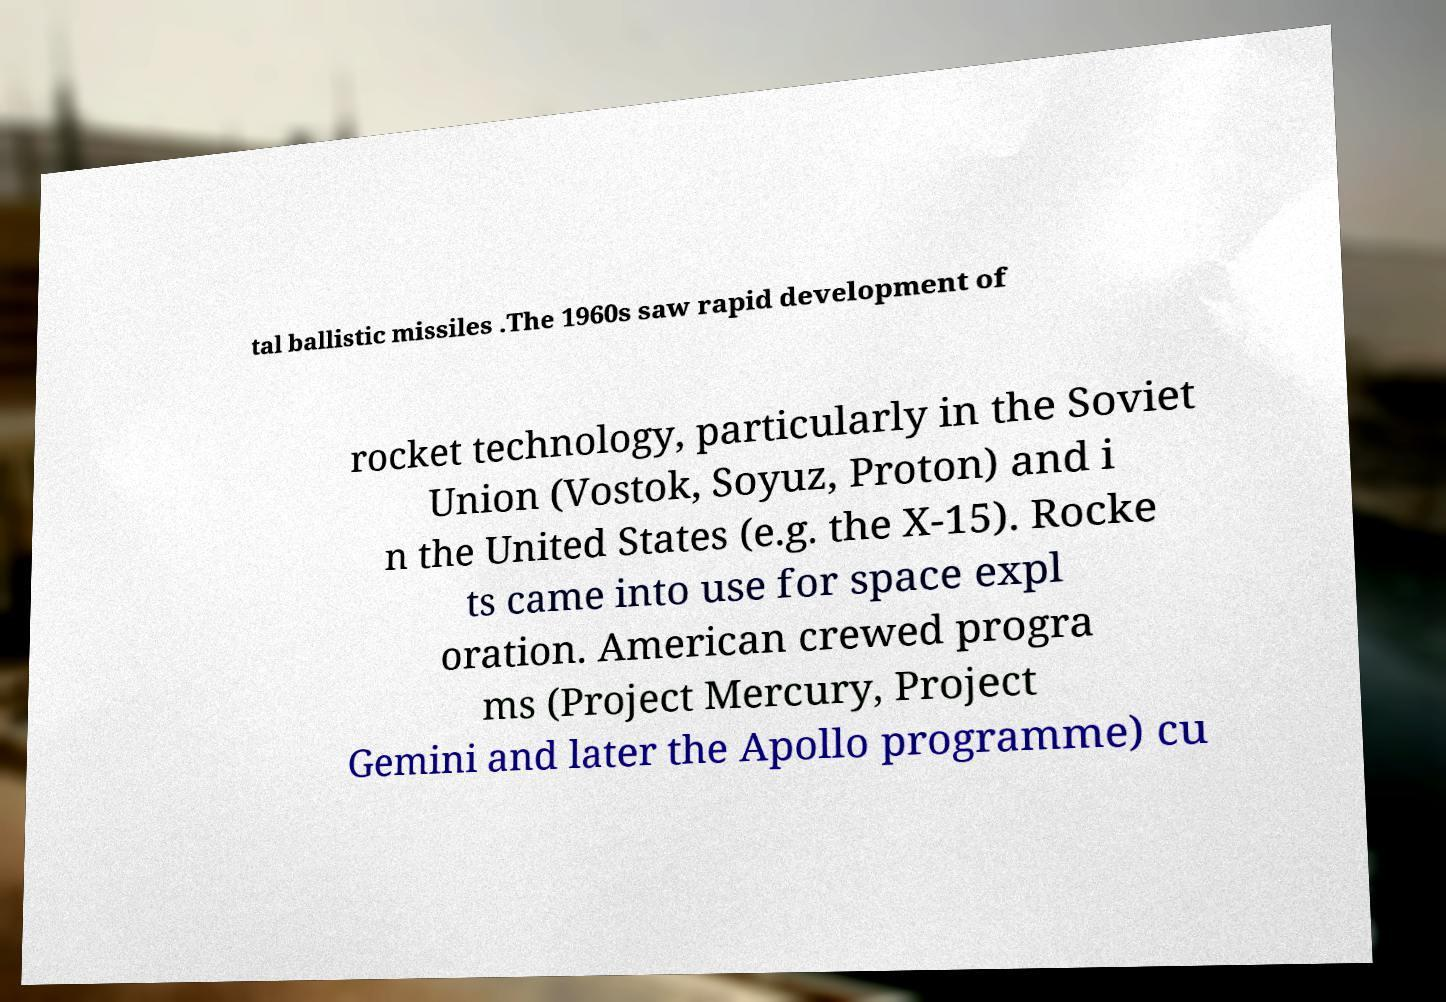There's text embedded in this image that I need extracted. Can you transcribe it verbatim? tal ballistic missiles .The 1960s saw rapid development of rocket technology, particularly in the Soviet Union (Vostok, Soyuz, Proton) and i n the United States (e.g. the X-15). Rocke ts came into use for space expl oration. American crewed progra ms (Project Mercury, Project Gemini and later the Apollo programme) cu 